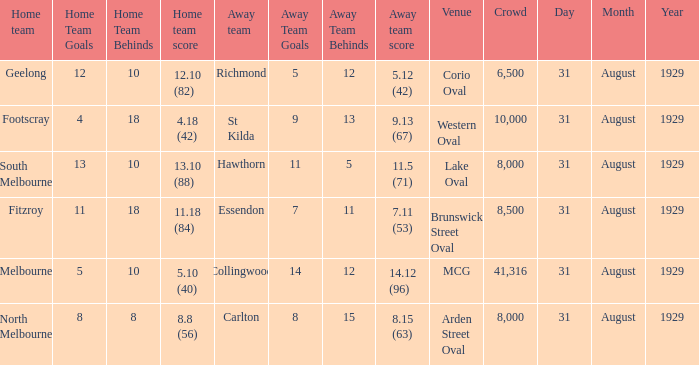What is the score of the away team when the crowd was larger than 8,000? 9.13 (67), 7.11 (53), 14.12 (96). 